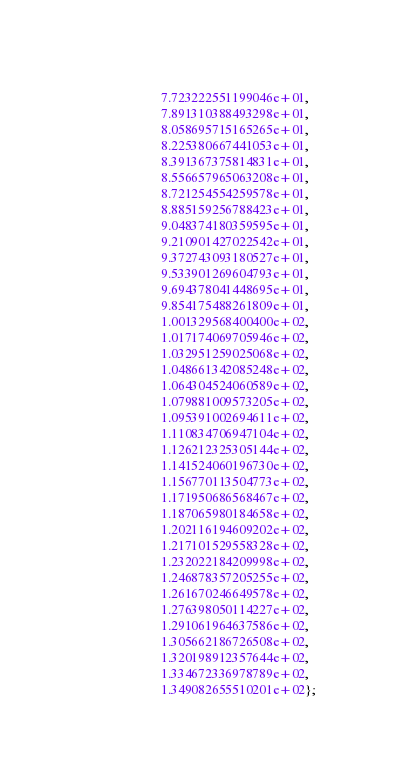Convert code to text. <code><loc_0><loc_0><loc_500><loc_500><_C_>                      7.723222551199046e+01,
                      7.891310388493298e+01,
                      8.058695715165265e+01,
                      8.225380667441053e+01,
                      8.391367375814831e+01,
                      8.556657965063208e+01,
                      8.721254554259578e+01,
                      8.885159256788423e+01,
                      9.048374180359595e+01,
                      9.210901427022542e+01,
                      9.372743093180527e+01,
                      9.533901269604793e+01,
                      9.694378041448695e+01,
                      9.854175488261809e+01,
                      1.001329568400400e+02,
                      1.017174069705946e+02,
                      1.032951259025068e+02,
                      1.048661342085248e+02,
                      1.064304524060589e+02,
                      1.079881009573205e+02,
                      1.095391002694611e+02,
                      1.110834706947104e+02,
                      1.126212325305144e+02,
                      1.141524060196730e+02,
                      1.156770113504773e+02,
                      1.171950686568467e+02,
                      1.187065980184658e+02,
                      1.202116194609202e+02,
                      1.217101529558328e+02,
                      1.232022184209998e+02,
                      1.246878357205255e+02,
                      1.261670246649578e+02,
                      1.276398050114227e+02,
                      1.291061964637586e+02,
                      1.305662186726508e+02,
                      1.320198912357644e+02,
                      1.334672336978789e+02,
                      1.349082655510201e+02};
</code> 